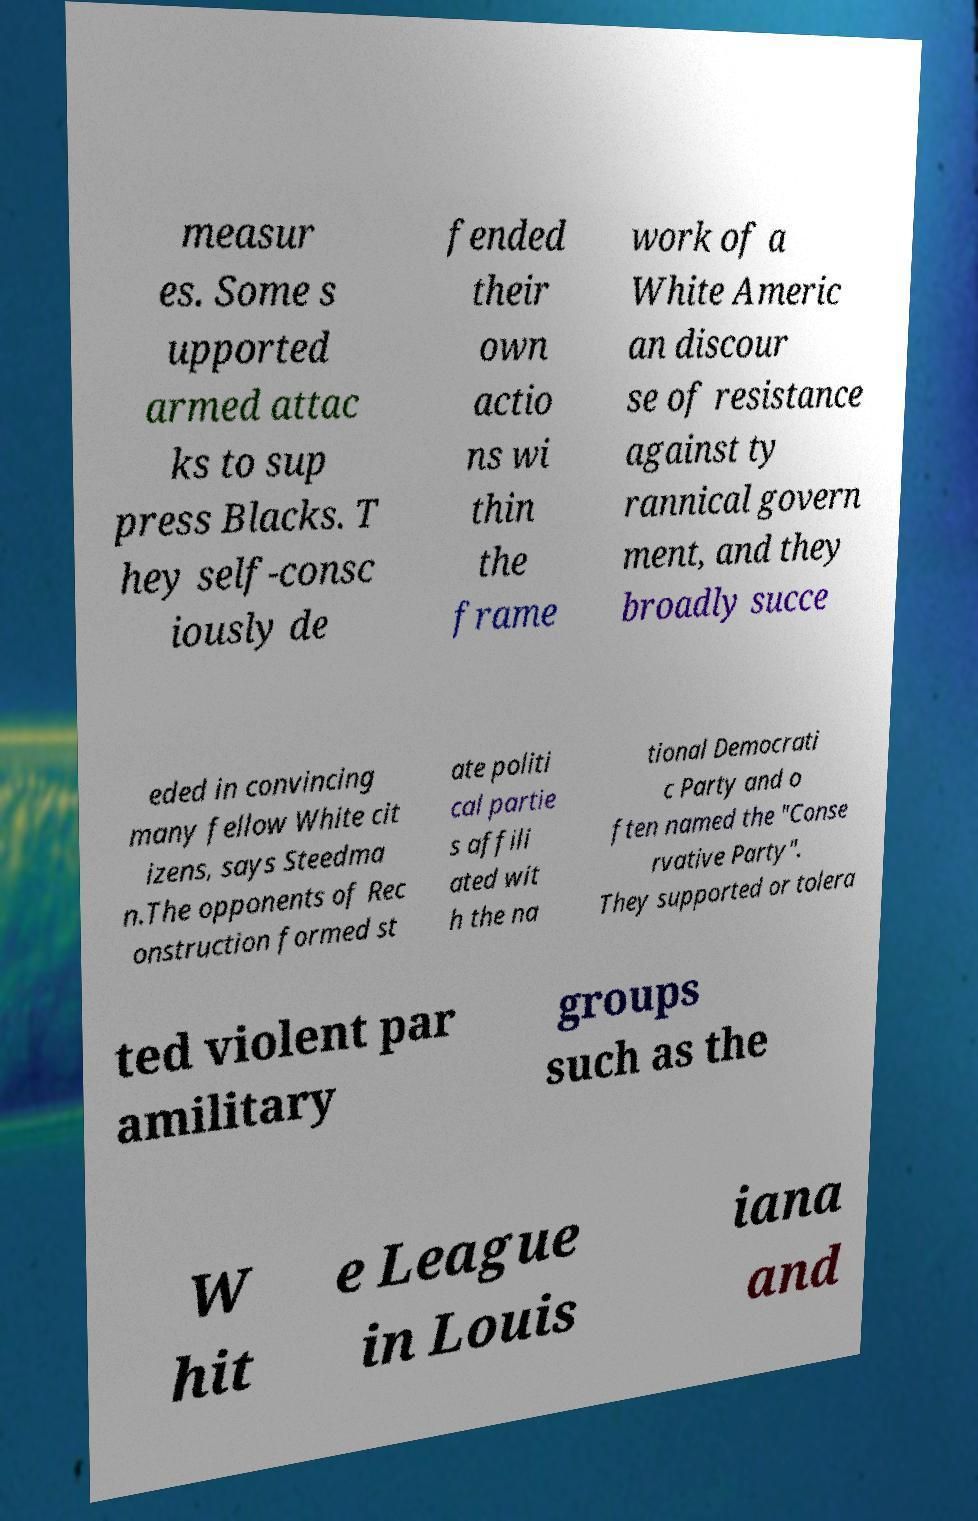Could you extract and type out the text from this image? measur es. Some s upported armed attac ks to sup press Blacks. T hey self-consc iously de fended their own actio ns wi thin the frame work of a White Americ an discour se of resistance against ty rannical govern ment, and they broadly succe eded in convincing many fellow White cit izens, says Steedma n.The opponents of Rec onstruction formed st ate politi cal partie s affili ated wit h the na tional Democrati c Party and o ften named the "Conse rvative Party". They supported or tolera ted violent par amilitary groups such as the W hit e League in Louis iana and 